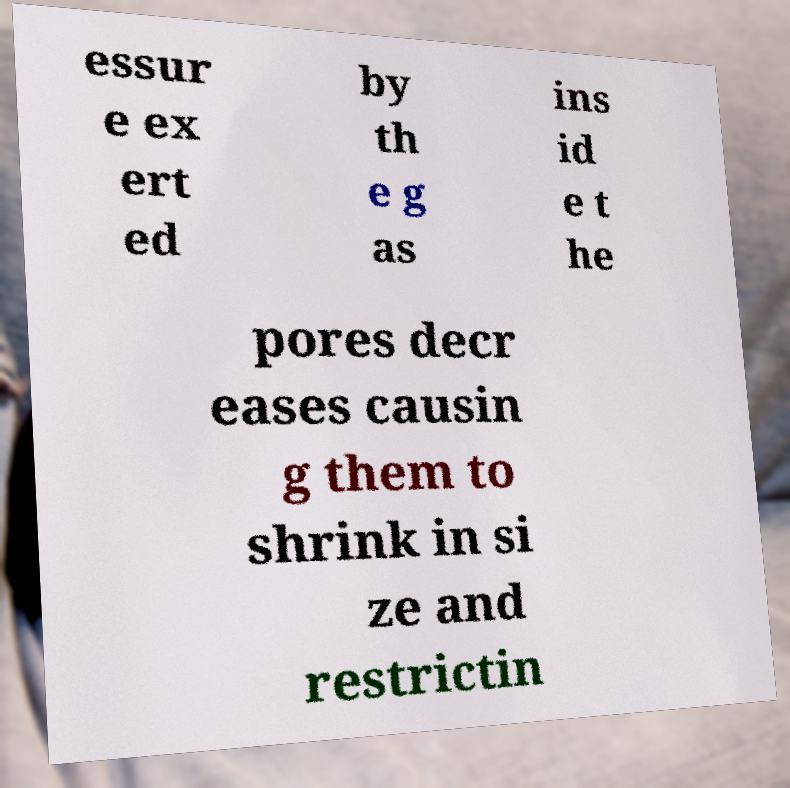Can you read and provide the text displayed in the image?This photo seems to have some interesting text. Can you extract and type it out for me? essur e ex ert ed by th e g as ins id e t he pores decr eases causin g them to shrink in si ze and restrictin 